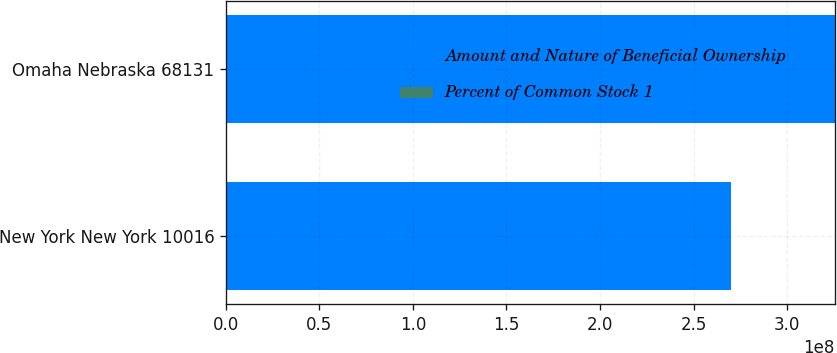Convert chart to OTSL. <chart><loc_0><loc_0><loc_500><loc_500><stacked_bar_chart><ecel><fcel>New York New York 10016<fcel>Omaha Nebraska 68131<nl><fcel>Amount and Nature of Beneficial Ownership<fcel>2.70097e+08<fcel>3.25442e+08<nl><fcel>Percent of Common Stock 1<fcel>22.1<fcel>26.7<nl></chart> 